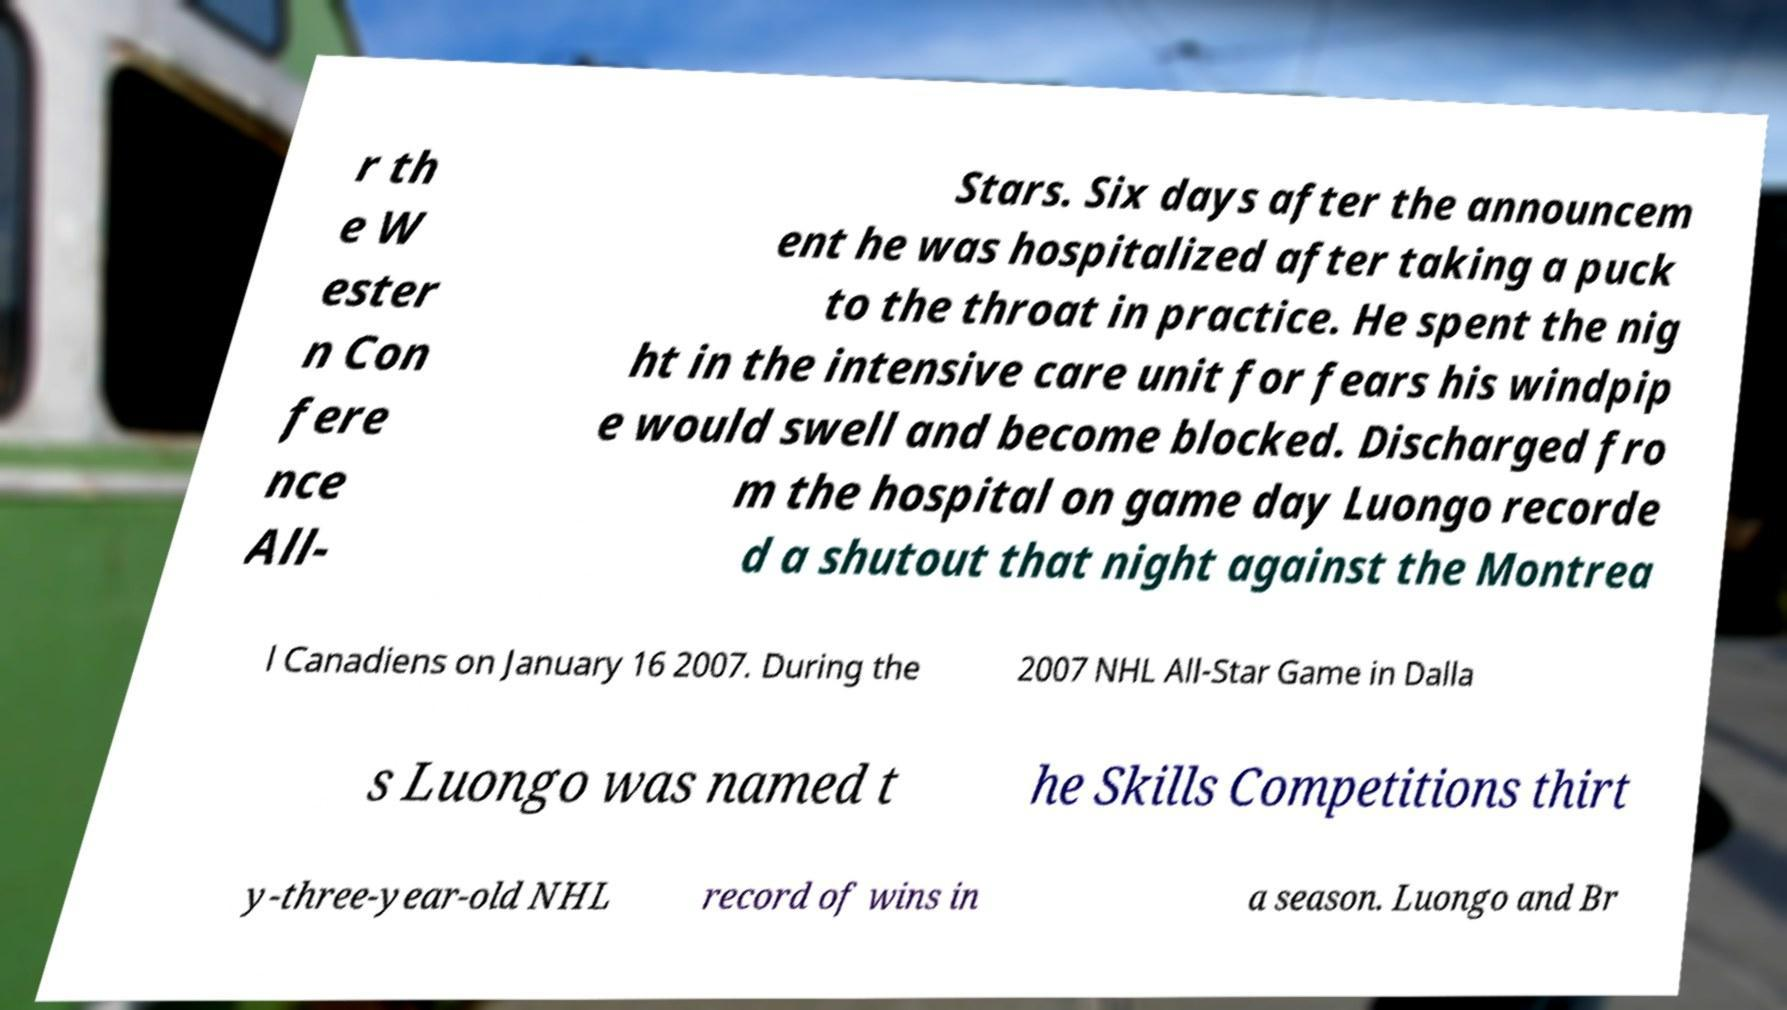I need the written content from this picture converted into text. Can you do that? r th e W ester n Con fere nce All- Stars. Six days after the announcem ent he was hospitalized after taking a puck to the throat in practice. He spent the nig ht in the intensive care unit for fears his windpip e would swell and become blocked. Discharged fro m the hospital on game day Luongo recorde d a shutout that night against the Montrea l Canadiens on January 16 2007. During the 2007 NHL All-Star Game in Dalla s Luongo was named t he Skills Competitions thirt y-three-year-old NHL record of wins in a season. Luongo and Br 